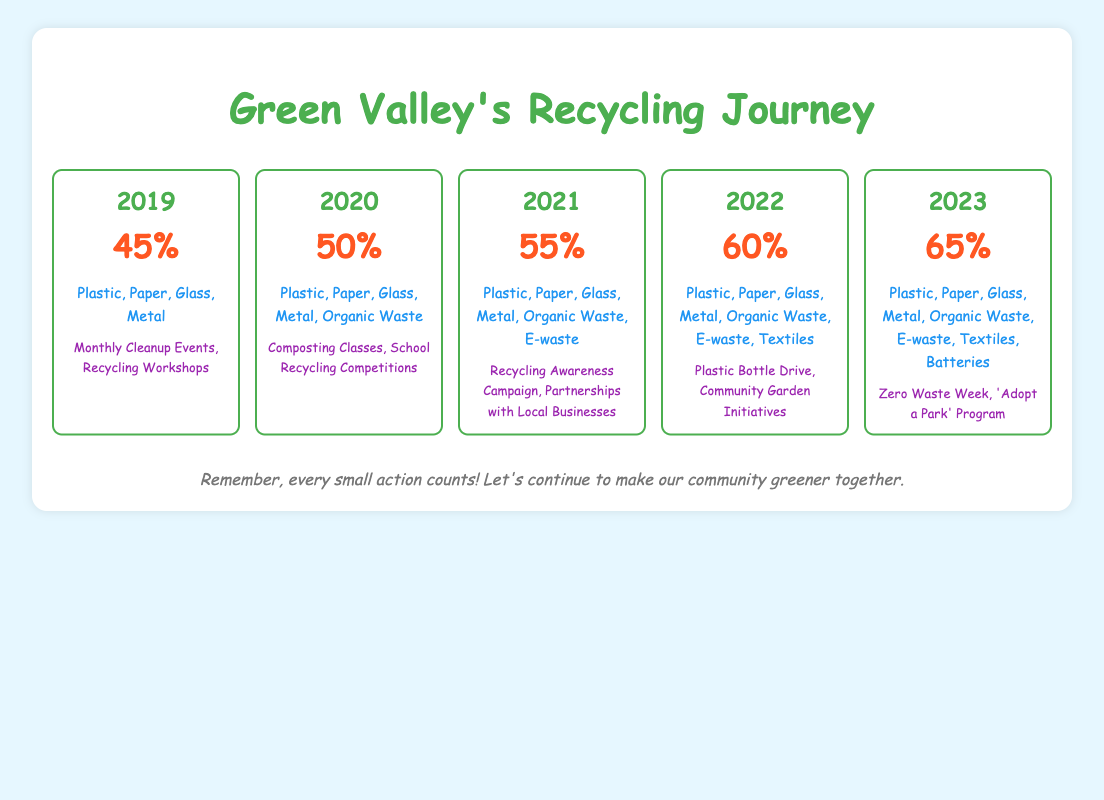What was the recycling rate in 2021? According to the table, the recycling rate for the year 2021 is directly stated as 55%.
Answer: 55% Which materials were recycled in 2022? The table lists the materials recycled in 2022 as Plastic, Paper, Glass, Metal, Organic Waste, E-waste, and Textiles.
Answer: Plastic, Paper, Glass, Metal, Organic Waste, E-waste, Textiles Did the recycling rate increase every year from 2019 to 2023? The recycling rates for each year are 45%, 50%, 55%, 60%, and 65% respectively, indicating a consistent increase each year.
Answer: Yes What is the total increase in the recycling rate from 2019 to 2023? The recycling rate in 2019 was 45% and in 2023 it is 65%. The increase is calculated as 65% - 45% = 20%.
Answer: 20% Which community programs were implemented in 2020? According to the table, the community programs in 2020 included Composting Classes and School Recycling Competitions.
Answer: Composting Classes, School Recycling Competitions How many different types of materials were recycled in 2023 compared to 2020? In 2020, the types of materials recycled included Plastic, Paper, Glass, Metal, and Organic Waste, totaling 5 materials. In 2023, the materials are Plastic, Paper, Glass, Metal, Organic Waste, E-waste, Textiles, and Batteries, totaling 8 materials. The difference is 8 - 5 = 3.
Answer: 3 Was E-waste recycled in Green Valley before 2021? E-waste was first listed as a recycled material in 2021, which means it was not recycled before that year.
Answer: No What was the average recycling rate from 2019 to 2023? To find the average, sum the recycling rates for the years: 45% + 50% + 55% + 60% + 65% = 275%. There are 5 data points, so the average is 275% / 5 = 55%.
Answer: 55% 